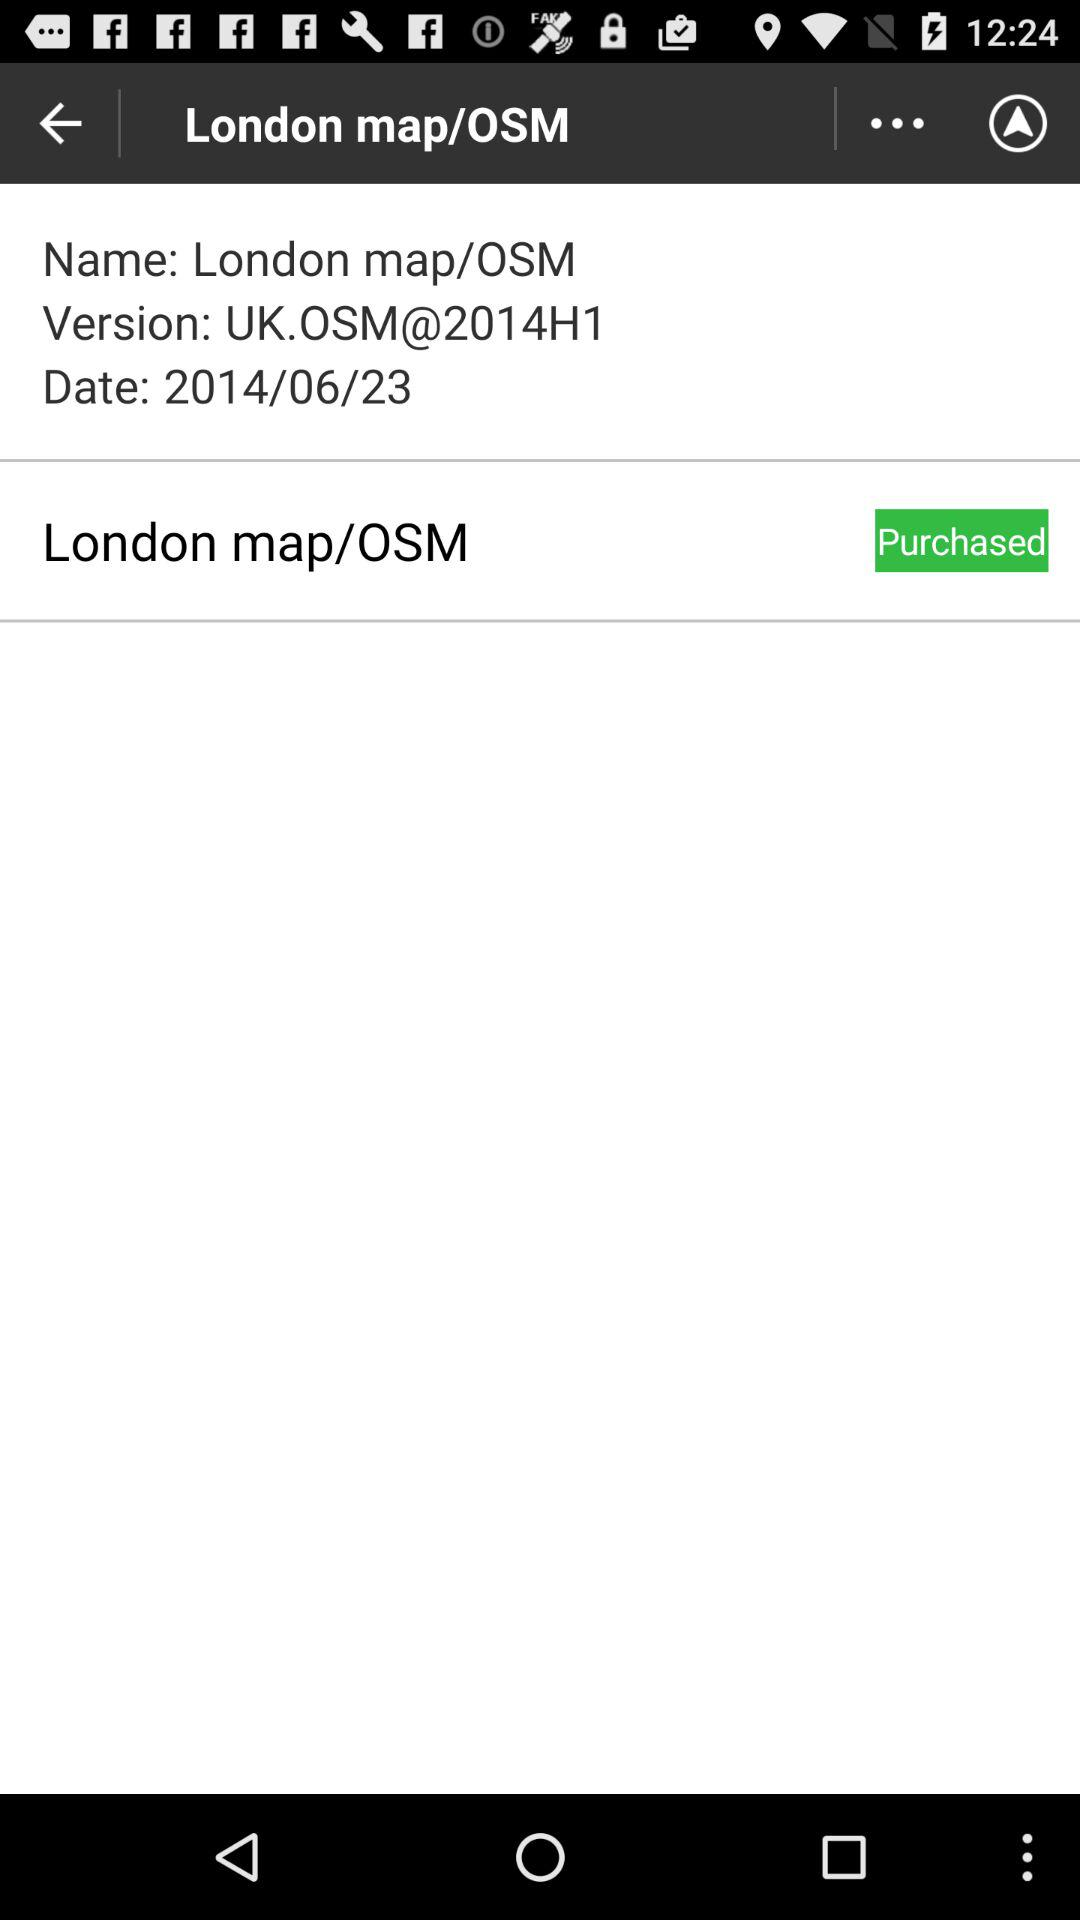What is the date? The date is June 23, 2014. 